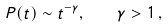Convert formula to latex. <formula><loc_0><loc_0><loc_500><loc_500>P ( t ) \sim t ^ { - \gamma } , \quad \gamma > 1 \, ,</formula> 